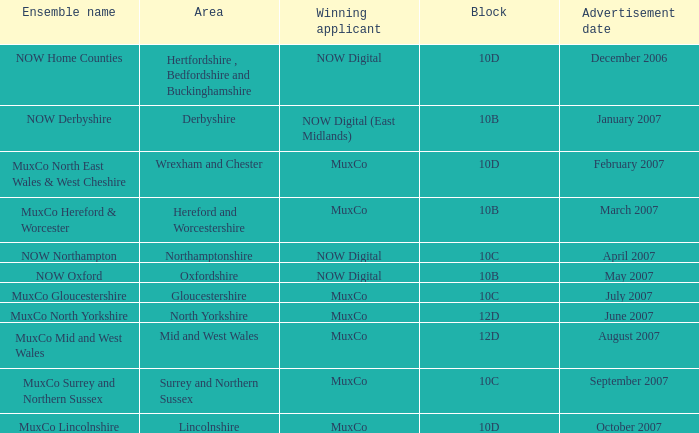Who is the Winning Applicant of Ensemble Name Muxco Lincolnshire in Block 10D? MuxCo. 